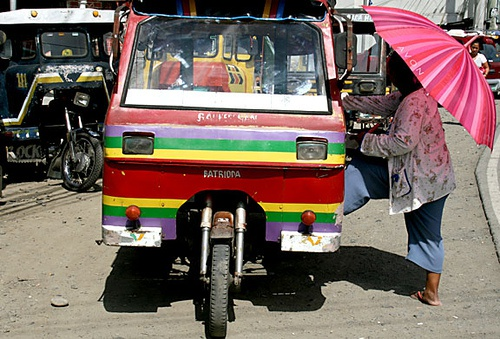Describe the objects in this image and their specific colors. I can see people in black, gray, and brown tones, umbrella in black, violet, salmon, brown, and lightpink tones, motorcycle in black, gray, and darkgray tones, car in black, maroon, purple, and blue tones, and people in black, white, maroon, and brown tones in this image. 